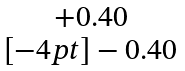Convert formula to latex. <formula><loc_0><loc_0><loc_500><loc_500>\begin{matrix} + 0 . 4 0 \\ [ - 4 p t ] - 0 . 4 0 \end{matrix}</formula> 